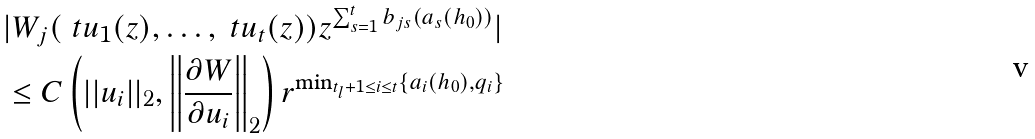Convert formula to latex. <formula><loc_0><loc_0><loc_500><loc_500>& | W _ { j } ( \ t u _ { 1 } ( z ) , \dots , \ t u _ { t } ( z ) ) z ^ { \sum _ { s = 1 } ^ { t } b _ { j s } ( a _ { s } ( h _ { 0 } ) ) } | \\ & \leq C \left ( | | u _ { i } | | _ { 2 } , \left | \left | \frac { \partial W } { \partial u _ { i } } \right | \right | _ { 2 } \right ) r ^ { \min _ { t _ { l } + 1 \leq i \leq t } \{ a _ { i } ( h _ { 0 } ) , q _ { i } \} }</formula> 